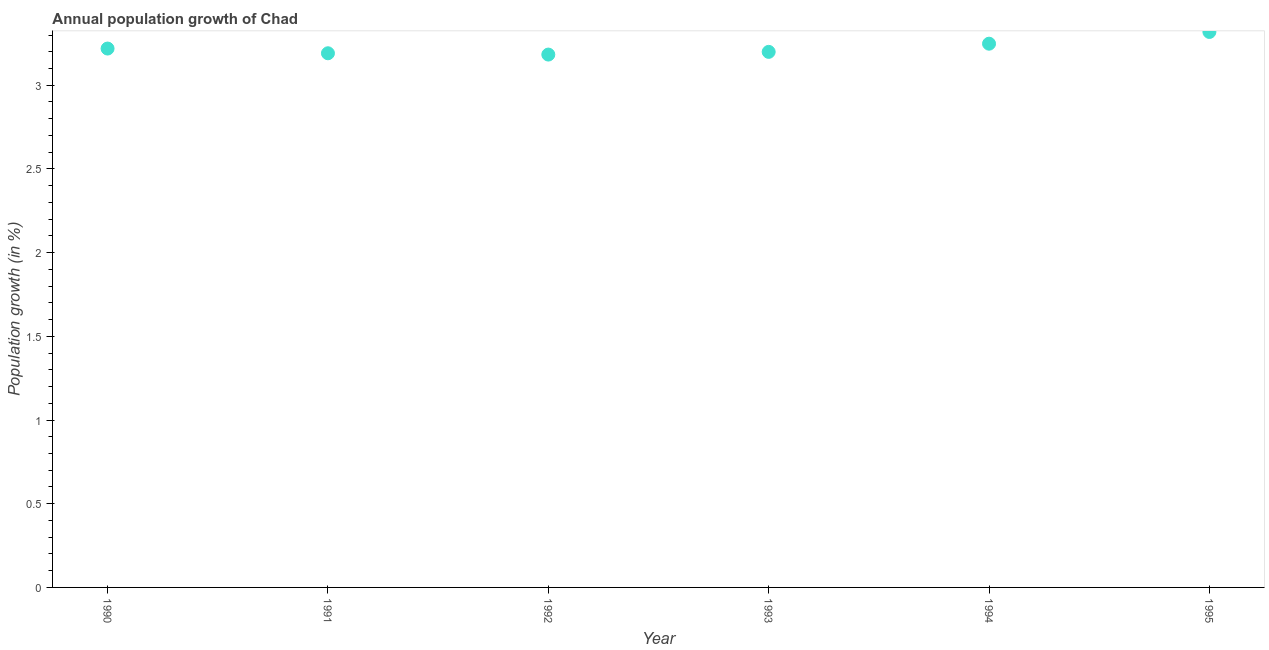What is the population growth in 1992?
Make the answer very short. 3.18. Across all years, what is the maximum population growth?
Your response must be concise. 3.32. Across all years, what is the minimum population growth?
Your answer should be compact. 3.18. In which year was the population growth maximum?
Provide a succinct answer. 1995. What is the sum of the population growth?
Provide a short and direct response. 19.36. What is the difference between the population growth in 1992 and 1995?
Offer a very short reply. -0.14. What is the average population growth per year?
Offer a very short reply. 3.23. What is the median population growth?
Ensure brevity in your answer.  3.21. Do a majority of the years between 1990 and 1992 (inclusive) have population growth greater than 1.7 %?
Provide a short and direct response. Yes. What is the ratio of the population growth in 1991 to that in 1992?
Offer a very short reply. 1. Is the population growth in 1992 less than that in 1995?
Offer a terse response. Yes. Is the difference between the population growth in 1993 and 1994 greater than the difference between any two years?
Your response must be concise. No. What is the difference between the highest and the second highest population growth?
Offer a very short reply. 0.07. What is the difference between the highest and the lowest population growth?
Offer a very short reply. 0.14. In how many years, is the population growth greater than the average population growth taken over all years?
Your answer should be compact. 2. Does the population growth monotonically increase over the years?
Your answer should be compact. No. How many dotlines are there?
Provide a succinct answer. 1. What is the difference between two consecutive major ticks on the Y-axis?
Make the answer very short. 0.5. Are the values on the major ticks of Y-axis written in scientific E-notation?
Offer a terse response. No. Does the graph contain any zero values?
Provide a succinct answer. No. Does the graph contain grids?
Provide a short and direct response. No. What is the title of the graph?
Offer a very short reply. Annual population growth of Chad. What is the label or title of the X-axis?
Keep it short and to the point. Year. What is the label or title of the Y-axis?
Your answer should be compact. Population growth (in %). What is the Population growth (in %) in 1990?
Provide a succinct answer. 3.22. What is the Population growth (in %) in 1991?
Your response must be concise. 3.19. What is the Population growth (in %) in 1992?
Keep it short and to the point. 3.18. What is the Population growth (in %) in 1993?
Your answer should be compact. 3.2. What is the Population growth (in %) in 1994?
Ensure brevity in your answer.  3.25. What is the Population growth (in %) in 1995?
Provide a short and direct response. 3.32. What is the difference between the Population growth (in %) in 1990 and 1991?
Your response must be concise. 0.03. What is the difference between the Population growth (in %) in 1990 and 1992?
Provide a short and direct response. 0.04. What is the difference between the Population growth (in %) in 1990 and 1993?
Provide a succinct answer. 0.02. What is the difference between the Population growth (in %) in 1990 and 1994?
Ensure brevity in your answer.  -0.03. What is the difference between the Population growth (in %) in 1990 and 1995?
Your response must be concise. -0.1. What is the difference between the Population growth (in %) in 1991 and 1992?
Give a very brief answer. 0.01. What is the difference between the Population growth (in %) in 1991 and 1993?
Provide a succinct answer. -0.01. What is the difference between the Population growth (in %) in 1991 and 1994?
Give a very brief answer. -0.06. What is the difference between the Population growth (in %) in 1991 and 1995?
Your answer should be very brief. -0.13. What is the difference between the Population growth (in %) in 1992 and 1993?
Make the answer very short. -0.02. What is the difference between the Population growth (in %) in 1992 and 1994?
Your answer should be very brief. -0.07. What is the difference between the Population growth (in %) in 1992 and 1995?
Offer a very short reply. -0.14. What is the difference between the Population growth (in %) in 1993 and 1994?
Offer a very short reply. -0.05. What is the difference between the Population growth (in %) in 1993 and 1995?
Ensure brevity in your answer.  -0.12. What is the difference between the Population growth (in %) in 1994 and 1995?
Your answer should be very brief. -0.07. What is the ratio of the Population growth (in %) in 1990 to that in 1993?
Your answer should be very brief. 1.01. What is the ratio of the Population growth (in %) in 1990 to that in 1994?
Make the answer very short. 0.99. What is the ratio of the Population growth (in %) in 1991 to that in 1992?
Your answer should be compact. 1. What is the ratio of the Population growth (in %) in 1991 to that in 1993?
Provide a succinct answer. 1. What is the ratio of the Population growth (in %) in 1992 to that in 1993?
Provide a succinct answer. 0.99. What is the ratio of the Population growth (in %) in 1992 to that in 1994?
Your answer should be very brief. 0.98. What is the ratio of the Population growth (in %) in 1992 to that in 1995?
Offer a very short reply. 0.96. What is the ratio of the Population growth (in %) in 1994 to that in 1995?
Make the answer very short. 0.98. 